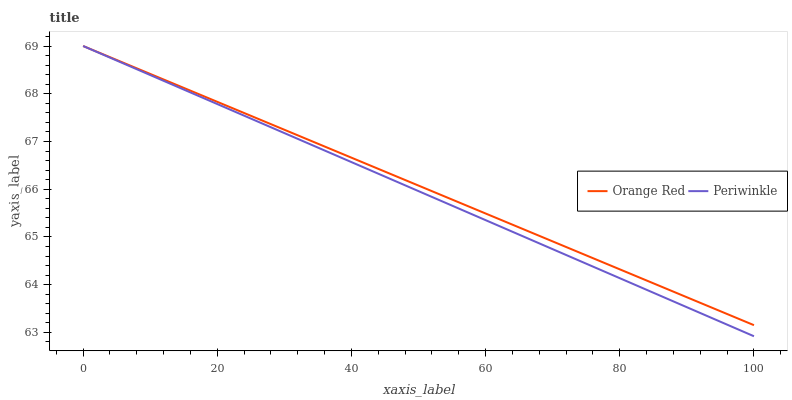Does Periwinkle have the minimum area under the curve?
Answer yes or no. Yes. Does Orange Red have the maximum area under the curve?
Answer yes or no. Yes. Does Orange Red have the minimum area under the curve?
Answer yes or no. No. Is Periwinkle the smoothest?
Answer yes or no. Yes. Is Orange Red the roughest?
Answer yes or no. Yes. Is Orange Red the smoothest?
Answer yes or no. No. Does Periwinkle have the lowest value?
Answer yes or no. Yes. Does Orange Red have the lowest value?
Answer yes or no. No. Does Orange Red have the highest value?
Answer yes or no. Yes. Does Periwinkle intersect Orange Red?
Answer yes or no. Yes. Is Periwinkle less than Orange Red?
Answer yes or no. No. Is Periwinkle greater than Orange Red?
Answer yes or no. No. 